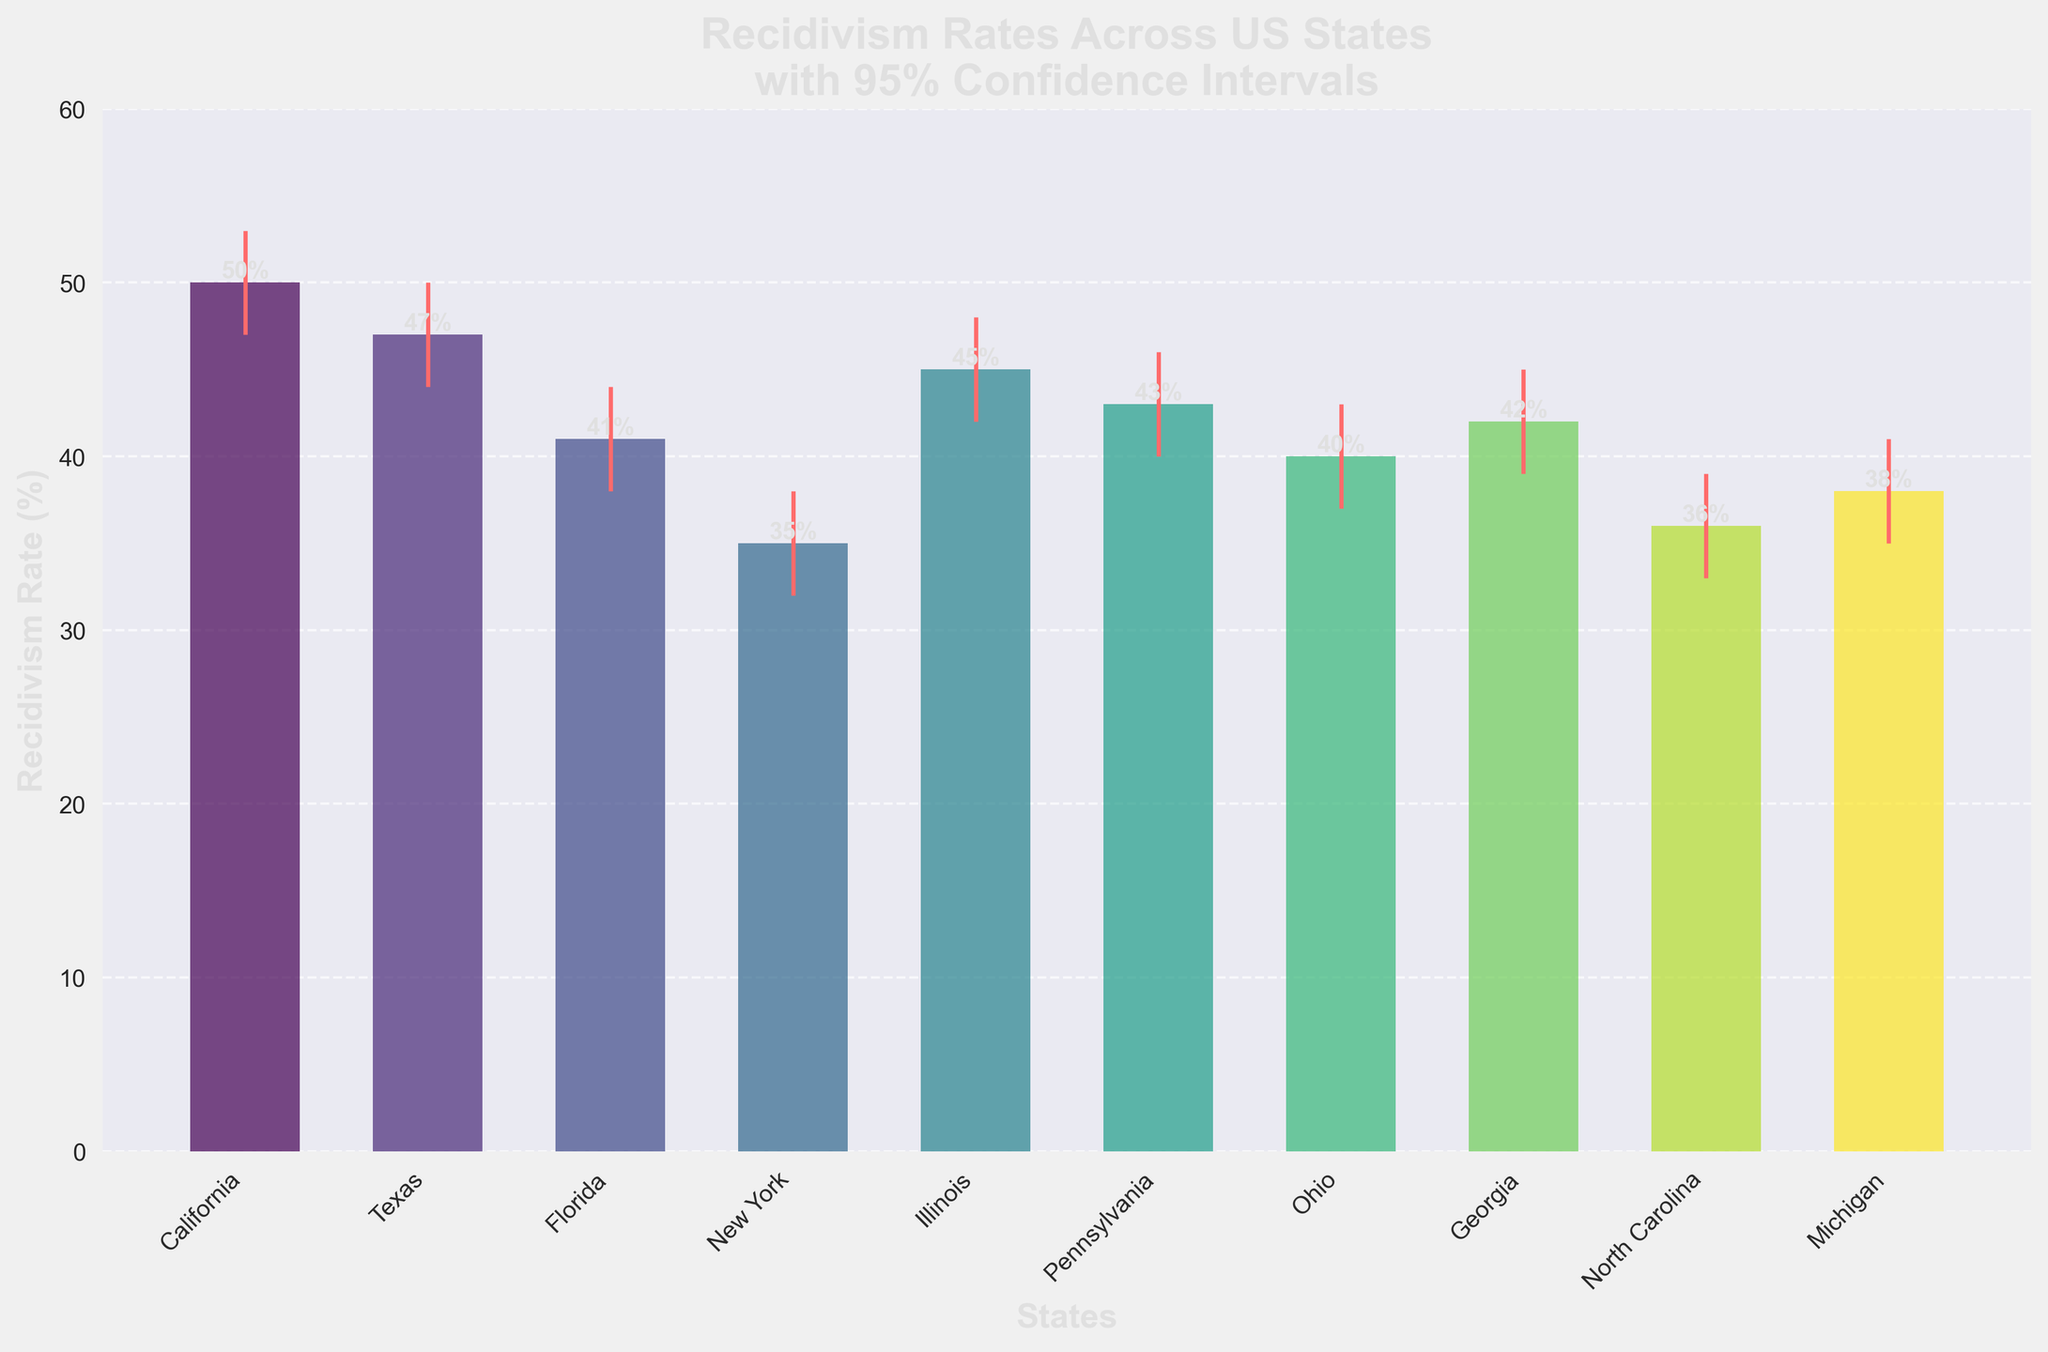Which state has the highest recidivism rate? California has the highest bar indicating it has the highest recidivism rate of 50%.
Answer: California What is the recidivism rate difference between California and New York? California's rate is 50% and New York's rate is 35%. The difference is 50% - 35% = 15%.
Answer: 15% Which state has the lowest upper bound of the 95% confidence interval? New York has the lowest upper bound at 38%, which is visually indicated by the top end of the error bar.
Answer: New York How many states have a recidivism rate of 40% or higher? States with rates of 40% or higher are California (50%), Texas (47%), Florida (41%), Illinois (45%), Pennsylvania (43%), Georgia (42%), and Ohio (40%). Count them: 7 states.
Answer: 7 Which states have overlapping confidence intervals for their recidivism rates? Texas (44%-50%) and Illinois (42%-48%) have overlapping intervals, as do Pennsylvania (40%-46%) and Georgia (39%-45%), among others. Multiple comparisons confirm these overlaps.
Answer: Texas, Illinois, Pennsylvania, Georgia Which state has the smallest error margin? The margin is calculated by (Upper Bound - Lower Bound). The smallest is New York with (38 - 32) = 6%, as shown by the relatively short error bar.
Answer: New York Compare the recidivism rates between North Carolina and Michigan. North Carolina has a rate of 36%, while Michigan has a rate of 38%. Therefore, Michigan has a 2% higher rate.
Answer: Michigan Is the confidence interval of Ohio wider than that of Pennsylvania? Ohio's interval is 37% to 43% (a range of 6%), while Pennsylvania's is 40% to 46% (also a range of 6%). Both intervals are equally wide.
Answer: No What is the average recidivism rate for the listed states? Sum the rates: 50+47+41+35+45+43+40+42+36+38 = 417. Divide by 10 states: 417/10 = 41.7%.
Answer: 41.7% 